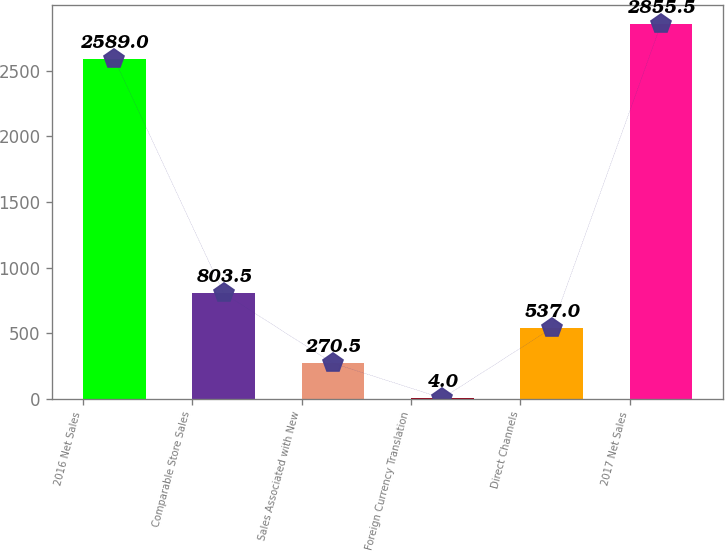Convert chart to OTSL. <chart><loc_0><loc_0><loc_500><loc_500><bar_chart><fcel>2016 Net Sales<fcel>Comparable Store Sales<fcel>Sales Associated with New<fcel>Foreign Currency Translation<fcel>Direct Channels<fcel>2017 Net Sales<nl><fcel>2589<fcel>803.5<fcel>270.5<fcel>4<fcel>537<fcel>2855.5<nl></chart> 